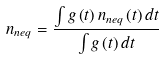<formula> <loc_0><loc_0><loc_500><loc_500>n _ { n e q } = \frac { \int g \left ( t \right ) n _ { n e q } \left ( t \right ) d t } { \int g \left ( t \right ) d t }</formula> 